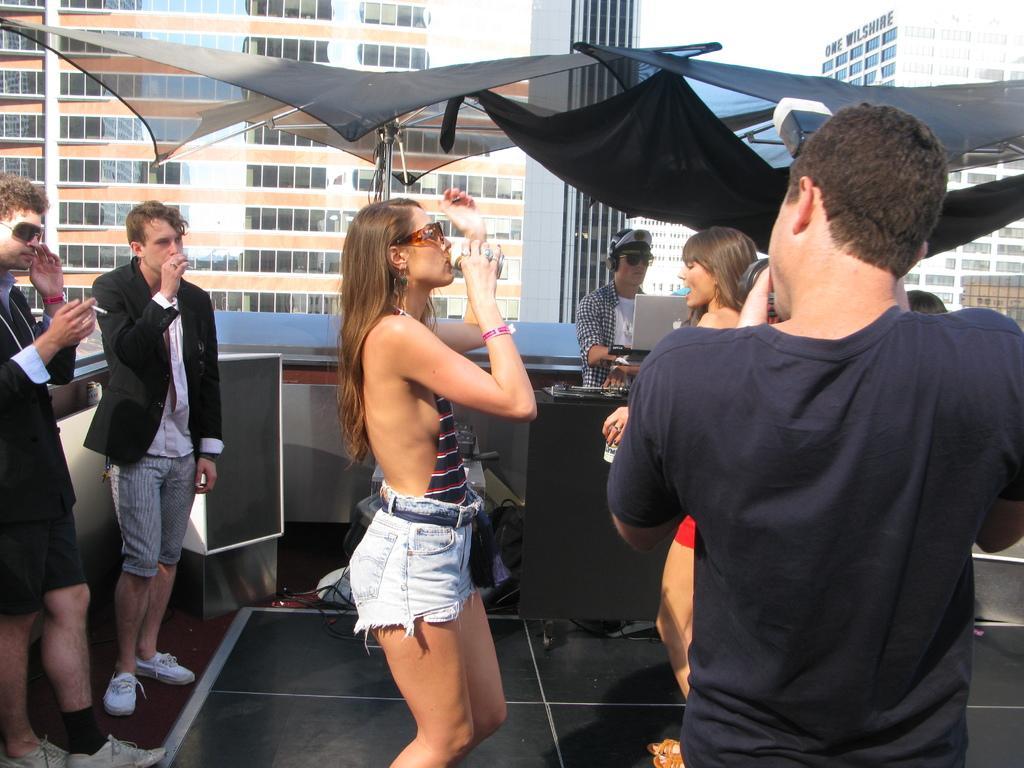Please provide a concise description of this image. In this image in the middle, there is a woman, she wears a dress, she is drinking, her hair is short. On the right there is a man, he wears a black t shirt, he is holding a camera, in front of him there is a woman. On the left there are two men. In the a background there is a man, laptop, table, tents, fingers, buildings and glass. 